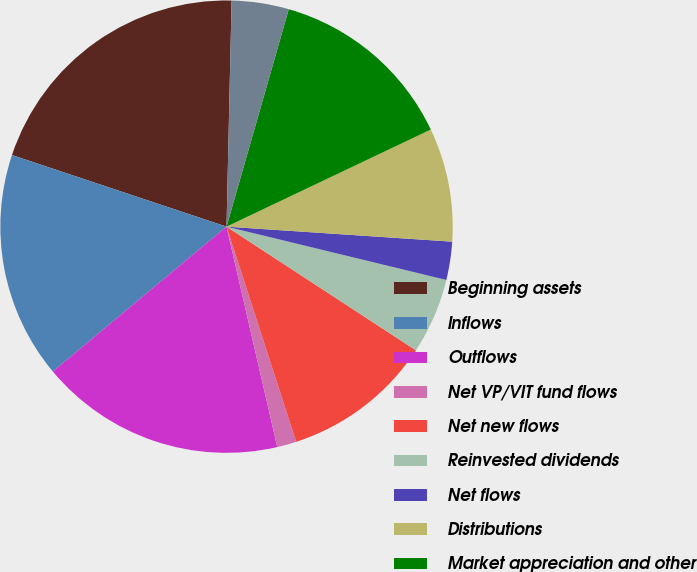Convert chart to OTSL. <chart><loc_0><loc_0><loc_500><loc_500><pie_chart><fcel>Beginning assets<fcel>Inflows<fcel>Outflows<fcel>Net VP/VIT fund flows<fcel>Net new flows<fcel>Reinvested dividends<fcel>Net flows<fcel>Distributions<fcel>Market appreciation and other<fcel>Foreign currency translation<nl><fcel>20.23%<fcel>16.19%<fcel>17.54%<fcel>1.38%<fcel>10.81%<fcel>5.42%<fcel>2.73%<fcel>8.12%<fcel>13.5%<fcel>4.08%<nl></chart> 